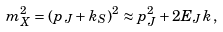Convert formula to latex. <formula><loc_0><loc_0><loc_500><loc_500>m _ { X } ^ { 2 } = ( p _ { J } + k _ { S } ) ^ { 2 } \approx p _ { J } ^ { 2 } + 2 E _ { J } k \, ,</formula> 